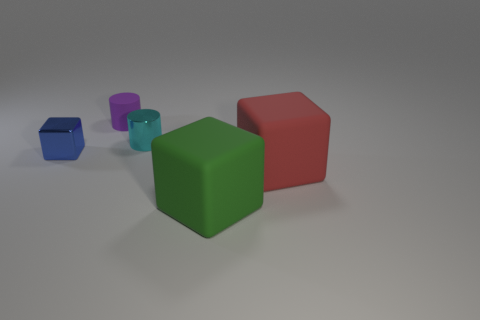Is the number of purple rubber things less than the number of shiny things?
Your answer should be compact. Yes. How many other objects are the same material as the small purple thing?
Your answer should be very brief. 2. There is a blue metallic thing that is the same shape as the big red rubber object; what size is it?
Keep it short and to the point. Small. Do the small cylinder in front of the tiny matte cylinder and the block that is left of the green thing have the same material?
Give a very brief answer. Yes. Is the number of red rubber things left of the large red block less than the number of blocks?
Provide a succinct answer. Yes. Is there any other thing that is the same shape as the red thing?
Keep it short and to the point. Yes. What is the color of the other tiny matte thing that is the same shape as the small cyan thing?
Ensure brevity in your answer.  Purple. There is a rubber cube that is behind the green rubber thing; is it the same size as the rubber cylinder?
Your answer should be compact. No. There is a rubber cube in front of the big cube to the right of the large green matte object; how big is it?
Ensure brevity in your answer.  Large. Is the green cube made of the same material as the big object that is on the right side of the large green rubber thing?
Ensure brevity in your answer.  Yes. 